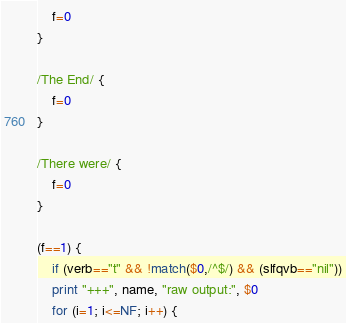Convert code to text. <code><loc_0><loc_0><loc_500><loc_500><_Awk_>    f=0
}

/The End/ {
    f=0
}

/There were/ {
    f=0
}

(f==1) {
    if (verb=="t" && !match($0,/^$/) && (slfqvb=="nil"))
	print "+++", name, "raw output:", $0
    for (i=1; i<=NF; i++) {</code> 